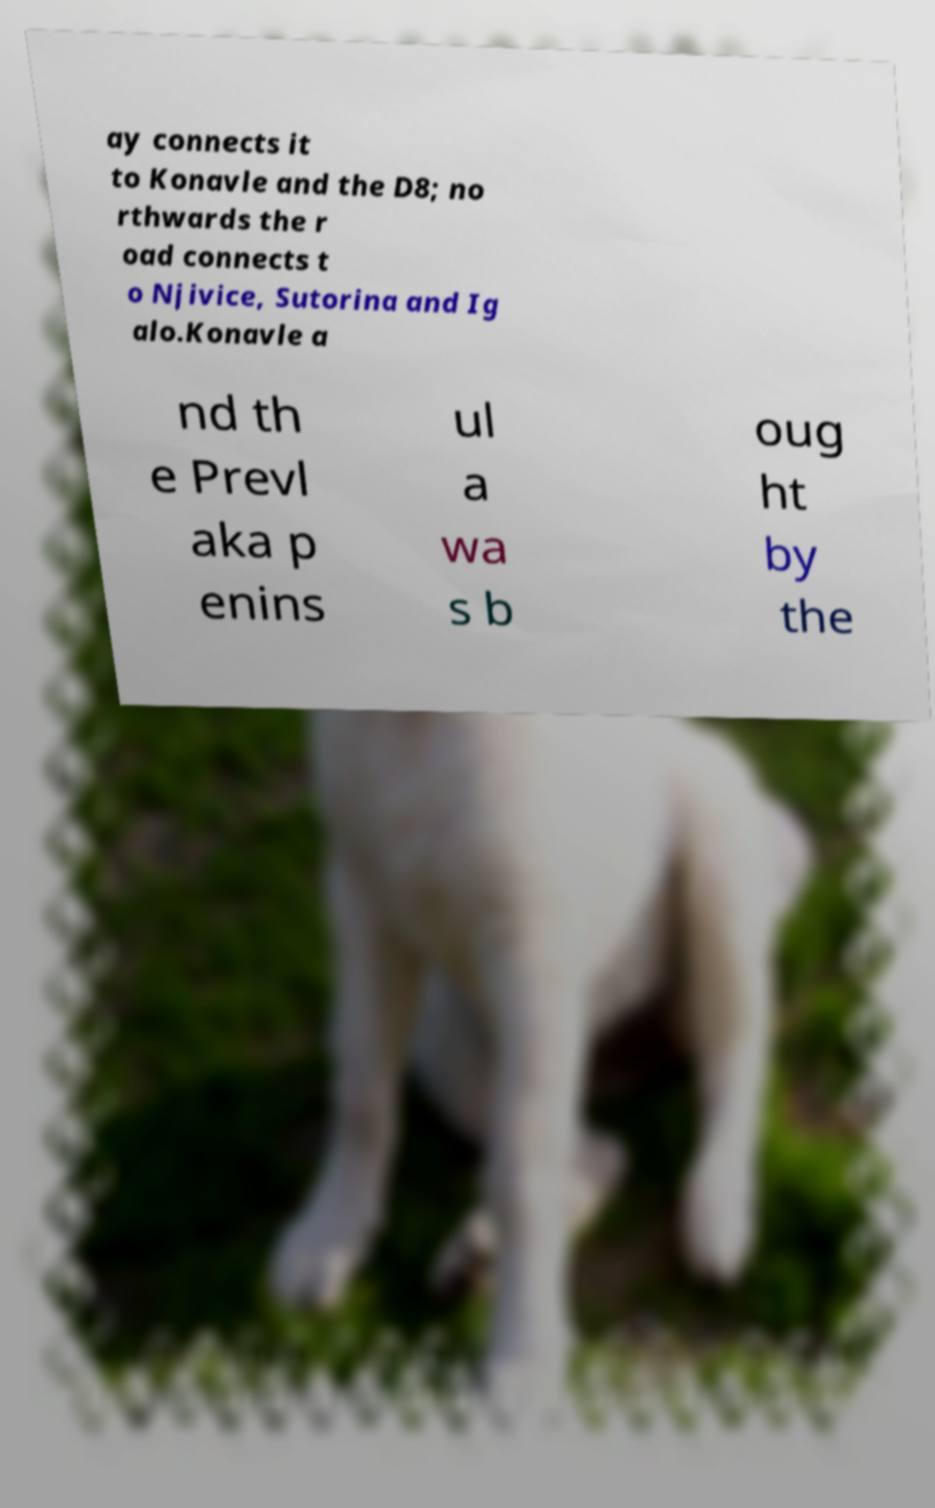Can you accurately transcribe the text from the provided image for me? ay connects it to Konavle and the D8; no rthwards the r oad connects t o Njivice, Sutorina and Ig alo.Konavle a nd th e Prevl aka p enins ul a wa s b oug ht by the 